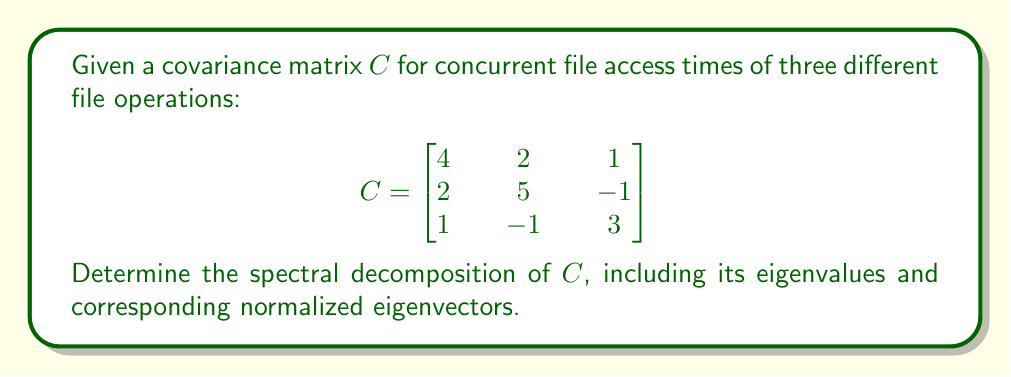Provide a solution to this math problem. To find the spectral decomposition of the covariance matrix $C$, we need to follow these steps:

1. Find the eigenvalues of $C$:
   - Compute the characteristic equation: $\det(C - \lambda I) = 0$
   - $\det\begin{bmatrix}
   4-\lambda & 2 & 1 \\
   2 & 5-\lambda & -1 \\
   1 & -1 & 3-\lambda
   \end{bmatrix} = 0$
   - Expanding, we get: $-\lambda^3 + 12\lambda^2 - 41\lambda + 40 = 0$
   - Solving this equation, we find the eigenvalues: $\lambda_1 = 8$, $\lambda_2 = 3$, $\lambda_3 = 1$

2. Find the eigenvectors for each eigenvalue:
   
   For $\lambda_1 = 8$:
   $(C - 8I)\vec{v_1} = \vec{0}$
   Solving this, we get $\vec{v_1} = k_1(2, 2, 1)$
   
   For $\lambda_2 = 3$:
   $(C - 3I)\vec{v_2} = \vec{0}$
   Solving this, we get $\vec{v_2} = k_2(-1, 1, 1)$
   
   For $\lambda_3 = 1$:
   $(C - I)\vec{v_3} = \vec{0}$
   Solving this, we get $\vec{v_3} = k_3(1, -1, 2)$

3. Normalize the eigenvectors:
   
   $\vec{u_1} = \frac{1}{\sqrt{9}}(2, 2, 1) = (\frac{2}{3}, \frac{2}{3}, \frac{1}{3})$
   
   $\vec{u_2} = \frac{1}{\sqrt{3}}(-1, 1, 1) = (-\frac{1}{\sqrt{3}}, \frac{1}{\sqrt{3}}, \frac{1}{\sqrt{3}})$
   
   $\vec{u_3} = \frac{1}{\sqrt{6}}(1, -1, 2) = (\frac{1}{\sqrt{6}}, -\frac{1}{\sqrt{6}}, \frac{2}{\sqrt{6}})$

4. The spectral decomposition is given by:
   $C = \lambda_1 \vec{u_1}\vec{u_1}^T + \lambda_2 \vec{u_2}\vec{u_2}^T + \lambda_3 \vec{u_3}\vec{u_3}^T$
Answer: $C = 8(\frac{2}{3}, \frac{2}{3}, \frac{1}{3})(\frac{2}{3}, \frac{2}{3}, \frac{1}{3})^T + 3(-\frac{1}{\sqrt{3}}, \frac{1}{\sqrt{3}}, \frac{1}{\sqrt{3}})(-\frac{1}{\sqrt{3}}, \frac{1}{\sqrt{3}}, \frac{1}{\sqrt{3}})^T + 1(\frac{1}{\sqrt{6}}, -\frac{1}{\sqrt{6}}, \frac{2}{\sqrt{6}})(\frac{1}{\sqrt{6}}, -\frac{1}{\sqrt{6}}, \frac{2}{\sqrt{6}})^T$ 